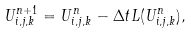Convert formula to latex. <formula><loc_0><loc_0><loc_500><loc_500>U ^ { n + 1 } _ { i , j , k } = U ^ { n } _ { i , j , k } - \Delta t L ( U ^ { n } _ { i , j , k } ) ,</formula> 